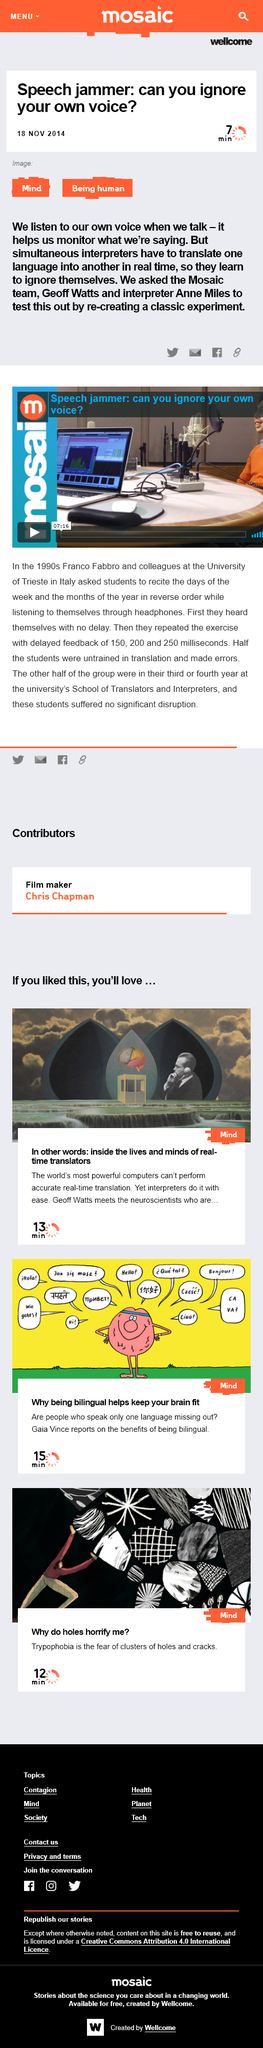Draw attention to some important aspects in this diagram. Simultaneous interpreters are responsible for translating one language into another in real time, accurately and quickly, during events such as conferences, meetings, and interviews. Because it aids us in evaluating the accuracy of our verbal expressions, we listen to our own voice when we talk. The speaker asked Anne Miles, the interpreter, to test out a speech jammer by re-creating a classic experiment. The three millisecond intervals used in the delayed feedback were 150, 200, and 250 milliseconds. The University of Trieste is located in Italy. 